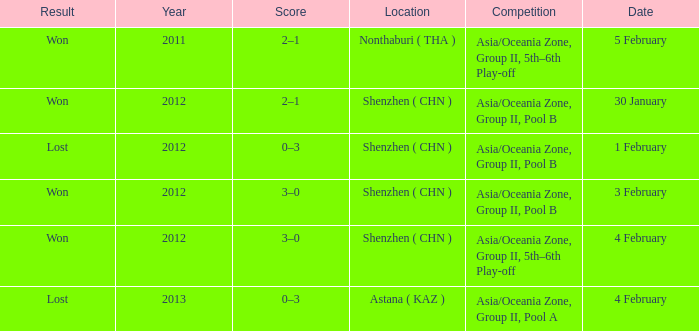What was the location for a year later than 2012? Astana ( KAZ ). 